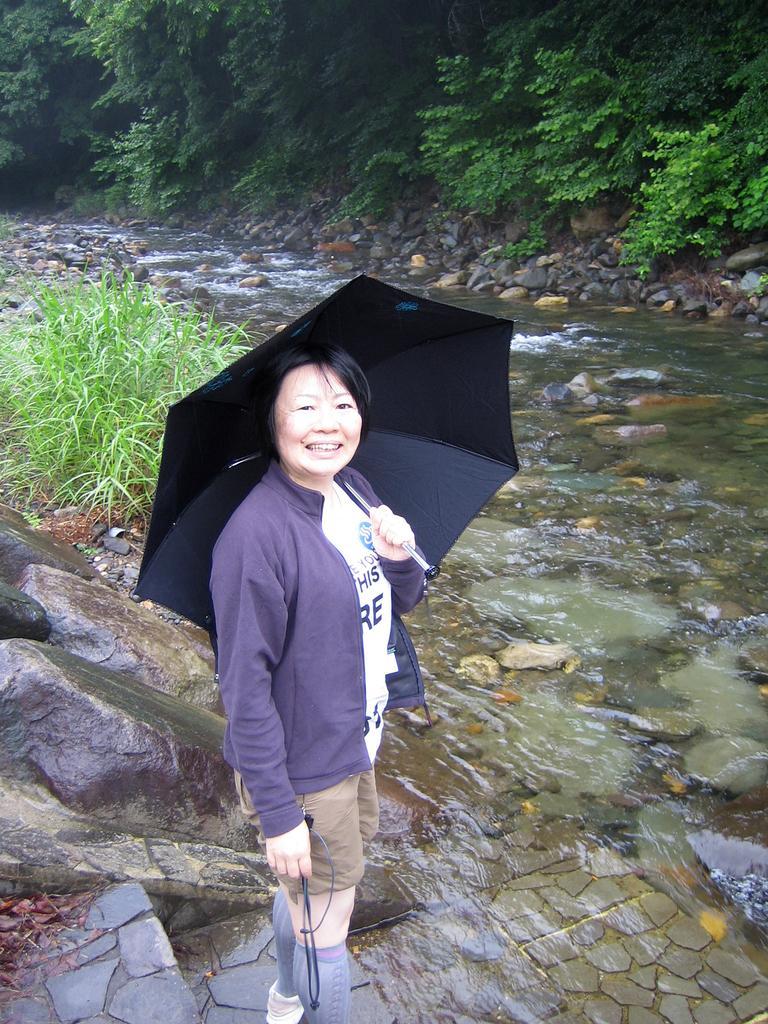Please provide a concise description of this image. In this image in front there is a person holding the umbrella. In the center of the image there is water. There are rocks. In the background of the image there are trees. 